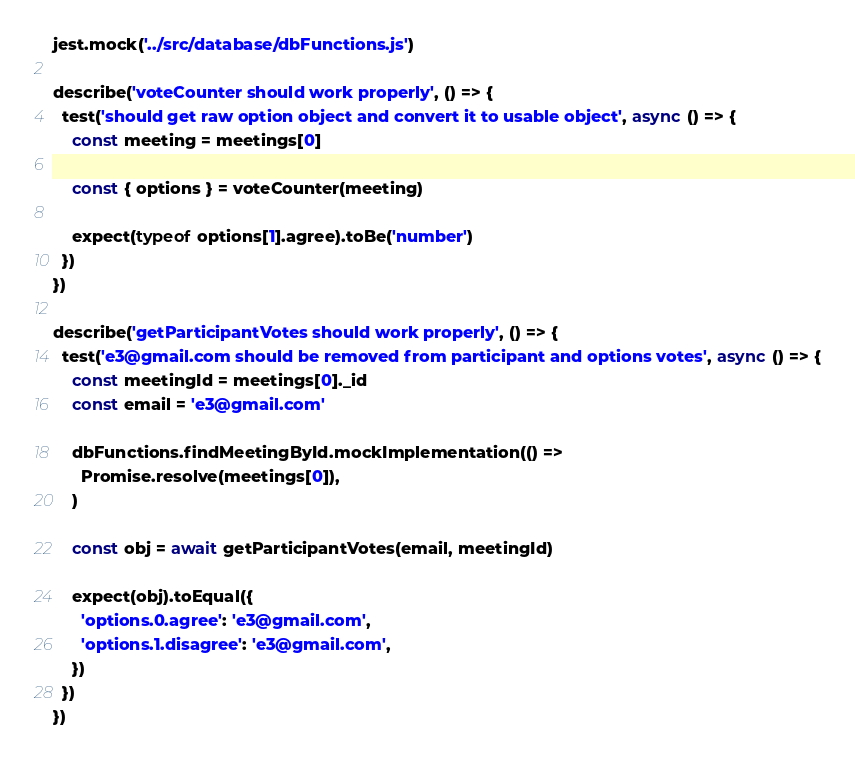<code> <loc_0><loc_0><loc_500><loc_500><_JavaScript_>jest.mock('../src/database/dbFunctions.js')

describe('voteCounter should work properly', () => {
  test('should get raw option object and convert it to usable object', async () => {
    const meeting = meetings[0]

    const { options } = voteCounter(meeting)

    expect(typeof options[1].agree).toBe('number')
  })
})

describe('getParticipantVotes should work properly', () => {
  test('e3@gmail.com should be removed from participant and options votes', async () => {
    const meetingId = meetings[0]._id
    const email = 'e3@gmail.com'

    dbFunctions.findMeetingById.mockImplementation(() =>
      Promise.resolve(meetings[0]),
    )

    const obj = await getParticipantVotes(email, meetingId)

    expect(obj).toEqual({
      'options.0.agree': 'e3@gmail.com',
      'options.1.disagree': 'e3@gmail.com',
    })
  })
})
</code> 